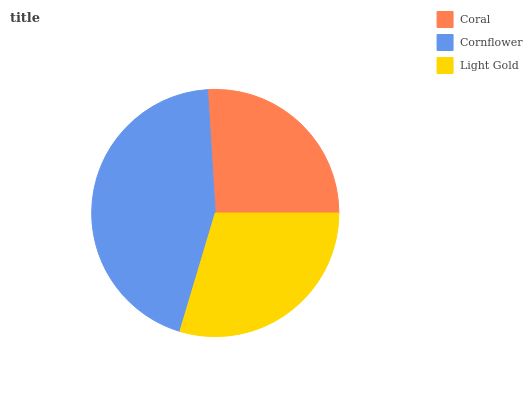Is Coral the minimum?
Answer yes or no. Yes. Is Cornflower the maximum?
Answer yes or no. Yes. Is Light Gold the minimum?
Answer yes or no. No. Is Light Gold the maximum?
Answer yes or no. No. Is Cornflower greater than Light Gold?
Answer yes or no. Yes. Is Light Gold less than Cornflower?
Answer yes or no. Yes. Is Light Gold greater than Cornflower?
Answer yes or no. No. Is Cornflower less than Light Gold?
Answer yes or no. No. Is Light Gold the high median?
Answer yes or no. Yes. Is Light Gold the low median?
Answer yes or no. Yes. Is Coral the high median?
Answer yes or no. No. Is Coral the low median?
Answer yes or no. No. 